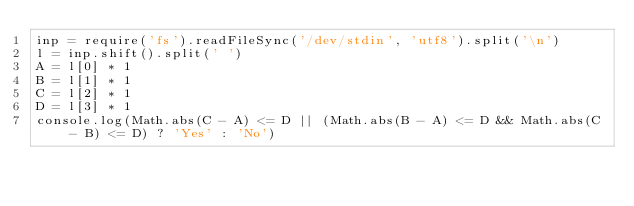Convert code to text. <code><loc_0><loc_0><loc_500><loc_500><_JavaScript_>inp = require('fs').readFileSync('/dev/stdin', 'utf8').split('\n')
l = inp.shift().split(' ')
A = l[0] * 1
B = l[1] * 1
C = l[2] * 1
D = l[3] * 1
console.log(Math.abs(C - A) <= D || (Math.abs(B - A) <= D && Math.abs(C - B) <= D) ? 'Yes' : 'No')</code> 